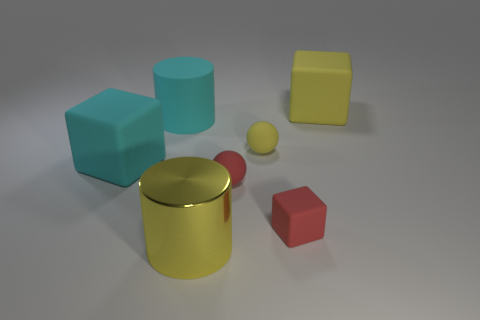There is a cyan thing that is the same shape as the large yellow metal thing; what size is it?
Ensure brevity in your answer.  Large. There is a large cyan cylinder; are there any small red rubber cubes on the left side of it?
Make the answer very short. No. Is the number of big matte things right of the red matte cube the same as the number of large cyan cylinders?
Keep it short and to the point. Yes. There is a cylinder behind the large cube that is to the left of the small red block; are there any big yellow cubes that are in front of it?
Your answer should be compact. No. What is the big yellow cylinder made of?
Offer a terse response. Metal. How many other things are there of the same shape as the big metal thing?
Your answer should be compact. 1. Do the big yellow shiny thing and the small yellow thing have the same shape?
Keep it short and to the point. No. What number of objects are rubber objects in front of the tiny red matte sphere or cubes that are to the left of the big yellow cylinder?
Offer a terse response. 2. What number of things are either large yellow matte blocks or cyan rubber cubes?
Give a very brief answer. 2. How many small blocks are to the right of the big yellow thing on the right side of the tiny yellow sphere?
Provide a succinct answer. 0. 